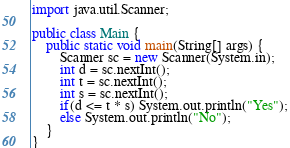<code> <loc_0><loc_0><loc_500><loc_500><_Java_>import java.util.Scanner;

public class Main {
    public static void main(String[] args) {
        Scanner sc = new Scanner(System.in);
        int d = sc.nextInt();
        int t = sc.nextInt();
        int s = sc.nextInt();
        if(d <= t * s) System.out.println("Yes");
        else System.out.println("No");
    }
}</code> 